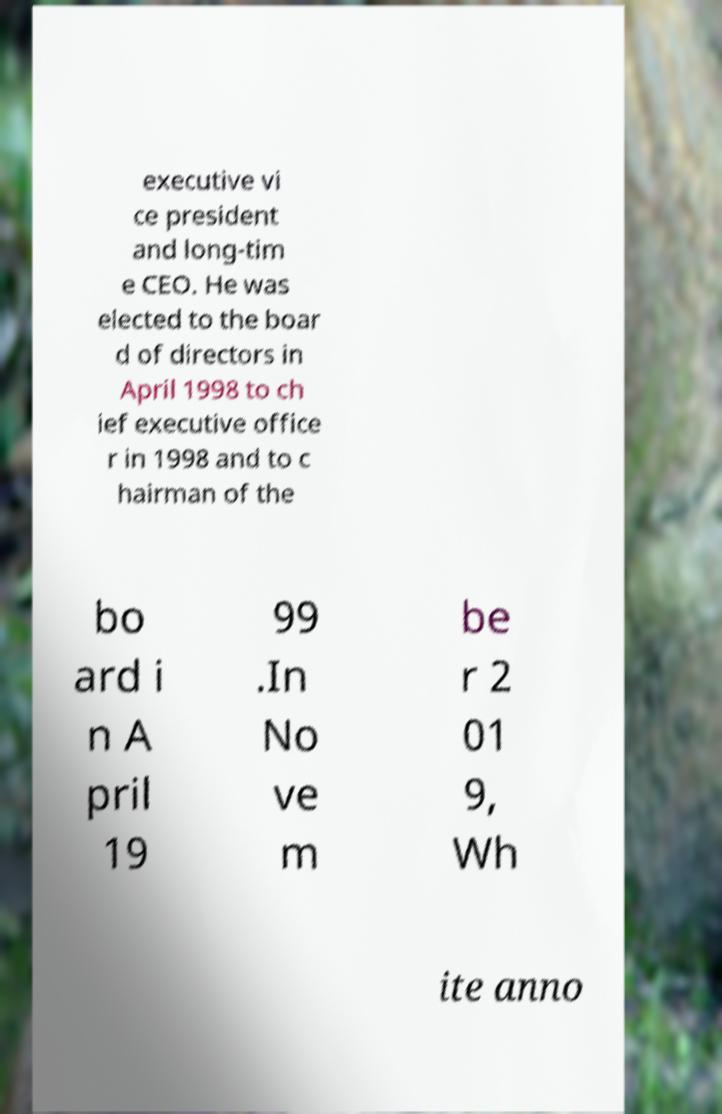Could you extract and type out the text from this image? executive vi ce president and long-tim e CEO. He was elected to the boar d of directors in April 1998 to ch ief executive office r in 1998 and to c hairman of the bo ard i n A pril 19 99 .In No ve m be r 2 01 9, Wh ite anno 